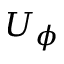<formula> <loc_0><loc_0><loc_500><loc_500>U _ { \phi }</formula> 